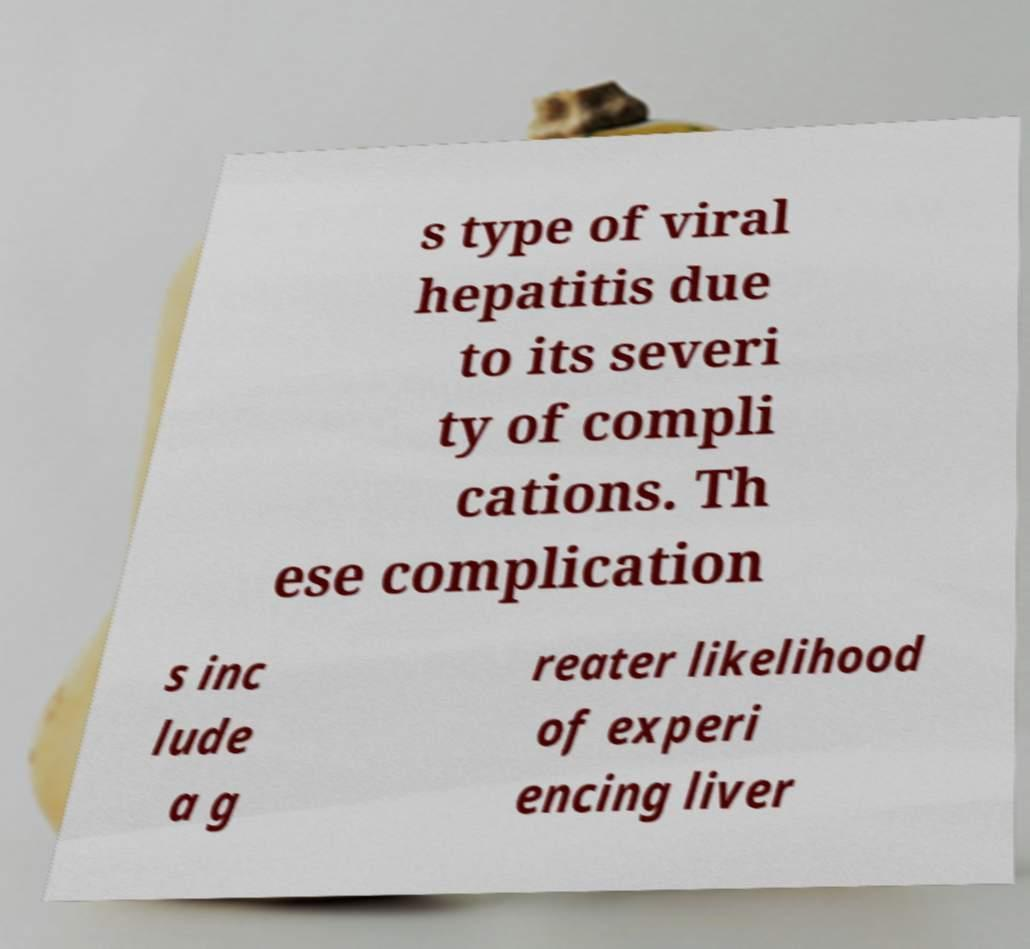What messages or text are displayed in this image? I need them in a readable, typed format. s type of viral hepatitis due to its severi ty of compli cations. Th ese complication s inc lude a g reater likelihood of experi encing liver 